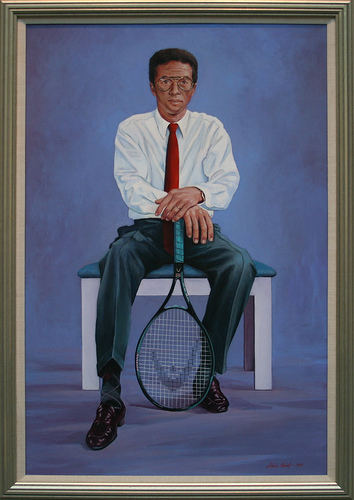Please provide the bounding box coordinate of the region this sentence describes: blue background behind man. The blue background behind the man is roughly within coordinates [0.63, 0.1, 0.74, 0.44]. 